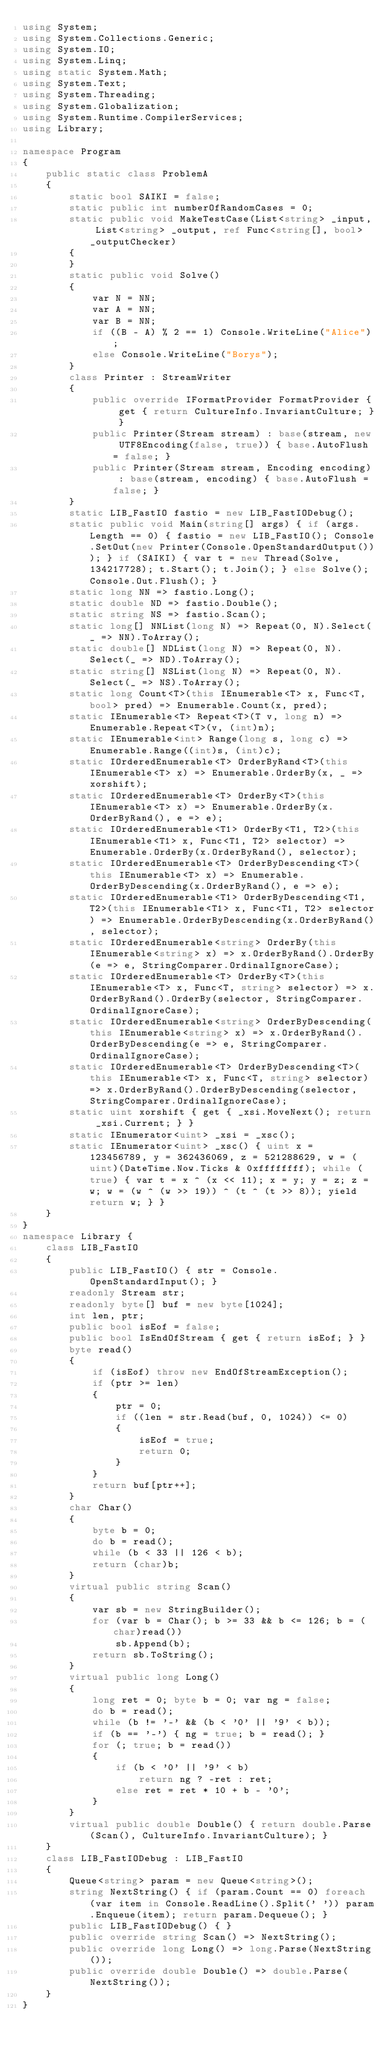<code> <loc_0><loc_0><loc_500><loc_500><_C#_>using System;
using System.Collections.Generic;
using System.IO;
using System.Linq;
using static System.Math;
using System.Text;
using System.Threading;
using System.Globalization;
using System.Runtime.CompilerServices;
using Library;

namespace Program
{
    public static class ProblemA
    {
        static bool SAIKI = false;
        static public int numberOfRandomCases = 0;
        static public void MakeTestCase(List<string> _input, List<string> _output, ref Func<string[], bool> _outputChecker)
        {
        }
        static public void Solve()
        {
            var N = NN;
            var A = NN;
            var B = NN;
            if ((B - A) % 2 == 1) Console.WriteLine("Alice");
            else Console.WriteLine("Borys");
        }
        class Printer : StreamWriter
        {
            public override IFormatProvider FormatProvider { get { return CultureInfo.InvariantCulture; } }
            public Printer(Stream stream) : base(stream, new UTF8Encoding(false, true)) { base.AutoFlush = false; }
            public Printer(Stream stream, Encoding encoding) : base(stream, encoding) { base.AutoFlush = false; }
        }
        static LIB_FastIO fastio = new LIB_FastIODebug();
        static public void Main(string[] args) { if (args.Length == 0) { fastio = new LIB_FastIO(); Console.SetOut(new Printer(Console.OpenStandardOutput())); } if (SAIKI) { var t = new Thread(Solve, 134217728); t.Start(); t.Join(); } else Solve(); Console.Out.Flush(); }
        static long NN => fastio.Long();
        static double ND => fastio.Double();
        static string NS => fastio.Scan();
        static long[] NNList(long N) => Repeat(0, N).Select(_ => NN).ToArray();
        static double[] NDList(long N) => Repeat(0, N).Select(_ => ND).ToArray();
        static string[] NSList(long N) => Repeat(0, N).Select(_ => NS).ToArray();
        static long Count<T>(this IEnumerable<T> x, Func<T, bool> pred) => Enumerable.Count(x, pred);
        static IEnumerable<T> Repeat<T>(T v, long n) => Enumerable.Repeat<T>(v, (int)n);
        static IEnumerable<int> Range(long s, long c) => Enumerable.Range((int)s, (int)c);
        static IOrderedEnumerable<T> OrderByRand<T>(this IEnumerable<T> x) => Enumerable.OrderBy(x, _ => xorshift);
        static IOrderedEnumerable<T> OrderBy<T>(this IEnumerable<T> x) => Enumerable.OrderBy(x.OrderByRand(), e => e);
        static IOrderedEnumerable<T1> OrderBy<T1, T2>(this IEnumerable<T1> x, Func<T1, T2> selector) => Enumerable.OrderBy(x.OrderByRand(), selector);
        static IOrderedEnumerable<T> OrderByDescending<T>(this IEnumerable<T> x) => Enumerable.OrderByDescending(x.OrderByRand(), e => e);
        static IOrderedEnumerable<T1> OrderByDescending<T1, T2>(this IEnumerable<T1> x, Func<T1, T2> selector) => Enumerable.OrderByDescending(x.OrderByRand(), selector);
        static IOrderedEnumerable<string> OrderBy(this IEnumerable<string> x) => x.OrderByRand().OrderBy(e => e, StringComparer.OrdinalIgnoreCase);
        static IOrderedEnumerable<T> OrderBy<T>(this IEnumerable<T> x, Func<T, string> selector) => x.OrderByRand().OrderBy(selector, StringComparer.OrdinalIgnoreCase);
        static IOrderedEnumerable<string> OrderByDescending(this IEnumerable<string> x) => x.OrderByRand().OrderByDescending(e => e, StringComparer.OrdinalIgnoreCase);
        static IOrderedEnumerable<T> OrderByDescending<T>(this IEnumerable<T> x, Func<T, string> selector) => x.OrderByRand().OrderByDescending(selector, StringComparer.OrdinalIgnoreCase);
        static uint xorshift { get { _xsi.MoveNext(); return _xsi.Current; } }
        static IEnumerator<uint> _xsi = _xsc();
        static IEnumerator<uint> _xsc() { uint x = 123456789, y = 362436069, z = 521288629, w = (uint)(DateTime.Now.Ticks & 0xffffffff); while (true) { var t = x ^ (x << 11); x = y; y = z; z = w; w = (w ^ (w >> 19)) ^ (t ^ (t >> 8)); yield return w; } }
    }
}
namespace Library {
    class LIB_FastIO
    {
        public LIB_FastIO() { str = Console.OpenStandardInput(); }
        readonly Stream str;
        readonly byte[] buf = new byte[1024];
        int len, ptr;
        public bool isEof = false;
        public bool IsEndOfStream { get { return isEof; } }
        byte read()
        {
            if (isEof) throw new EndOfStreamException();
            if (ptr >= len)
            {
                ptr = 0;
                if ((len = str.Read(buf, 0, 1024)) <= 0)
                {
                    isEof = true;
                    return 0;
                }
            }
            return buf[ptr++];
        }
        char Char()
        {
            byte b = 0;
            do b = read();
            while (b < 33 || 126 < b);
            return (char)b;
        }
        virtual public string Scan()
        {
            var sb = new StringBuilder();
            for (var b = Char(); b >= 33 && b <= 126; b = (char)read())
                sb.Append(b);
            return sb.ToString();
        }
        virtual public long Long()
        {
            long ret = 0; byte b = 0; var ng = false;
            do b = read();
            while (b != '-' && (b < '0' || '9' < b));
            if (b == '-') { ng = true; b = read(); }
            for (; true; b = read())
            {
                if (b < '0' || '9' < b)
                    return ng ? -ret : ret;
                else ret = ret * 10 + b - '0';
            }
        }
        virtual public double Double() { return double.Parse(Scan(), CultureInfo.InvariantCulture); }
    }
    class LIB_FastIODebug : LIB_FastIO
    {
        Queue<string> param = new Queue<string>();
        string NextString() { if (param.Count == 0) foreach (var item in Console.ReadLine().Split(' ')) param.Enqueue(item); return param.Dequeue(); }
        public LIB_FastIODebug() { }
        public override string Scan() => NextString();
        public override long Long() => long.Parse(NextString());
        public override double Double() => double.Parse(NextString());
    }
}
</code> 